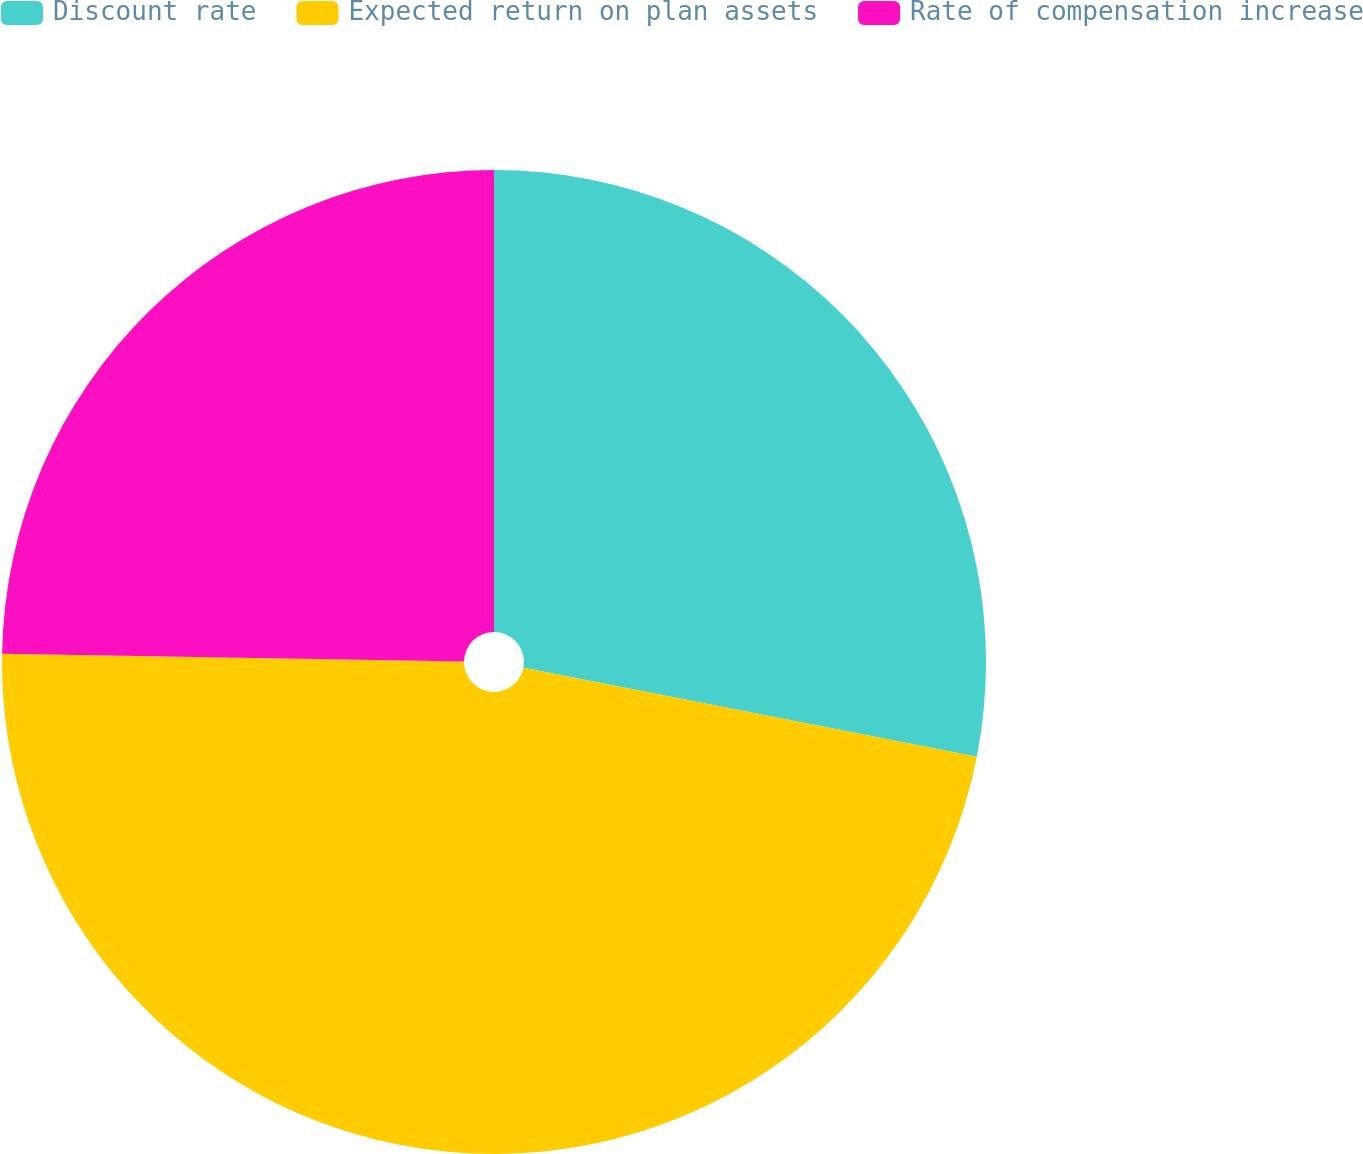Convert chart. <chart><loc_0><loc_0><loc_500><loc_500><pie_chart><fcel>Discount rate<fcel>Expected return on plan assets<fcel>Rate of compensation increase<nl><fcel>28.08%<fcel>47.18%<fcel>24.73%<nl></chart> 